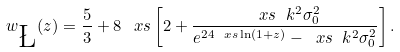<formula> <loc_0><loc_0><loc_500><loc_500>w _ { \L } ( z ) = \frac { 5 } { 3 } + 8 \, \ x s \left [ 2 + \frac { \ x s \ k ^ { 2 } \sigma _ { 0 } ^ { 2 } } { e ^ { 2 4 \ x s \ln ( 1 + z ) } - \ x s \ k ^ { 2 } \sigma _ { 0 } ^ { 2 } } \right ] .</formula> 